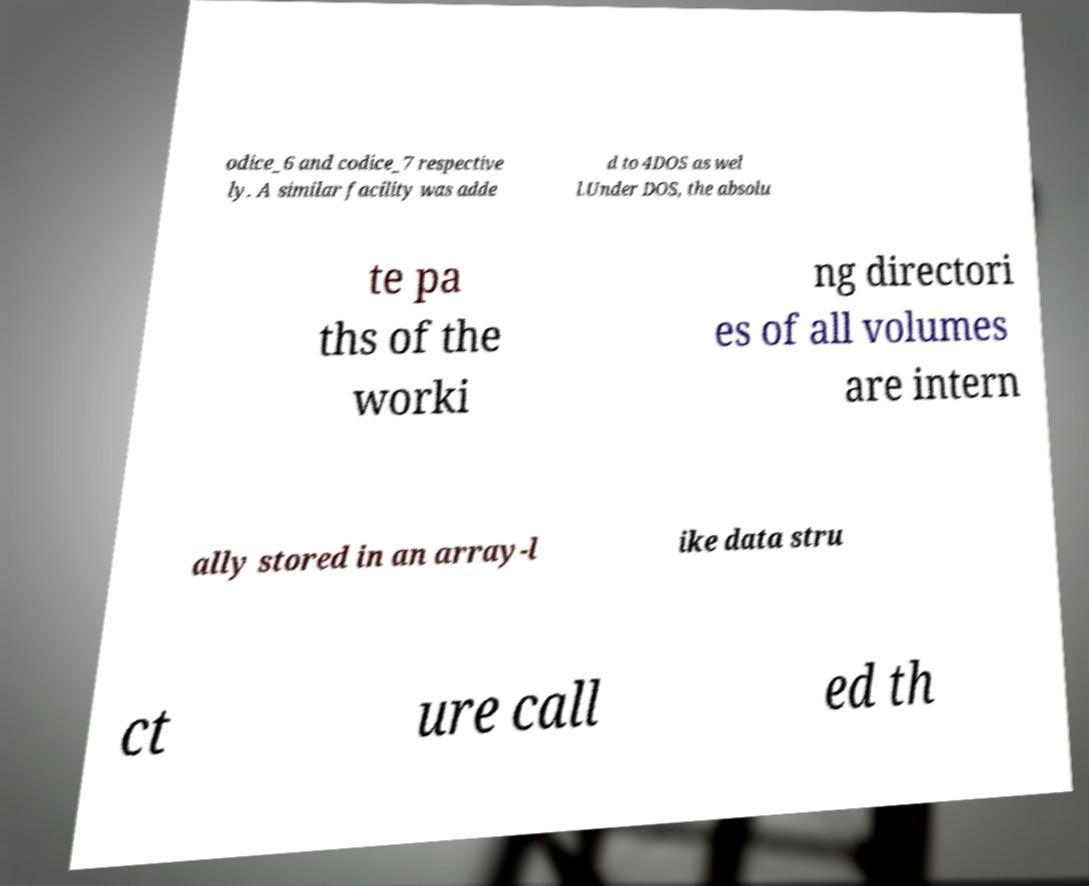Can you read and provide the text displayed in the image?This photo seems to have some interesting text. Can you extract and type it out for me? odice_6 and codice_7 respective ly. A similar facility was adde d to 4DOS as wel l.Under DOS, the absolu te pa ths of the worki ng directori es of all volumes are intern ally stored in an array-l ike data stru ct ure call ed th 